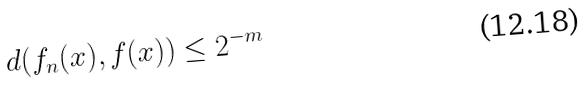<formula> <loc_0><loc_0><loc_500><loc_500>d ( f _ { n } ( x ) , f ( x ) ) \leq 2 ^ { - m }</formula> 